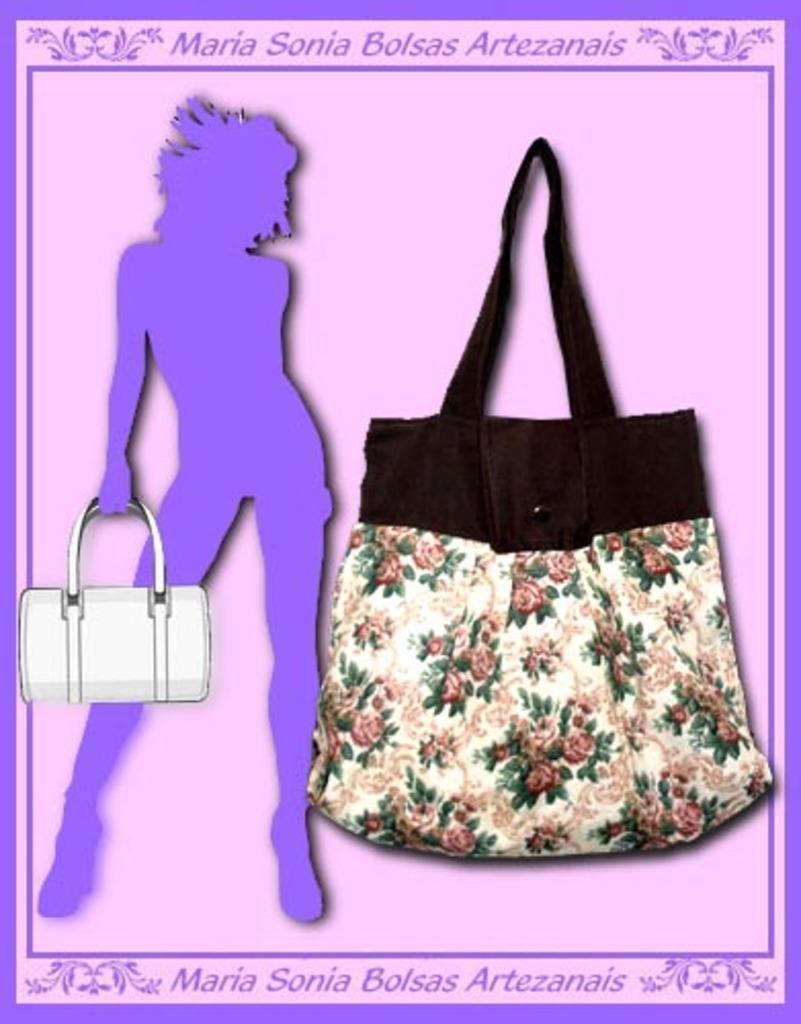In one or two sentences, can you explain what this image depicts? A bag in white and a floral design is hanged on a pink wall with a poster of a lady holding a bag. 